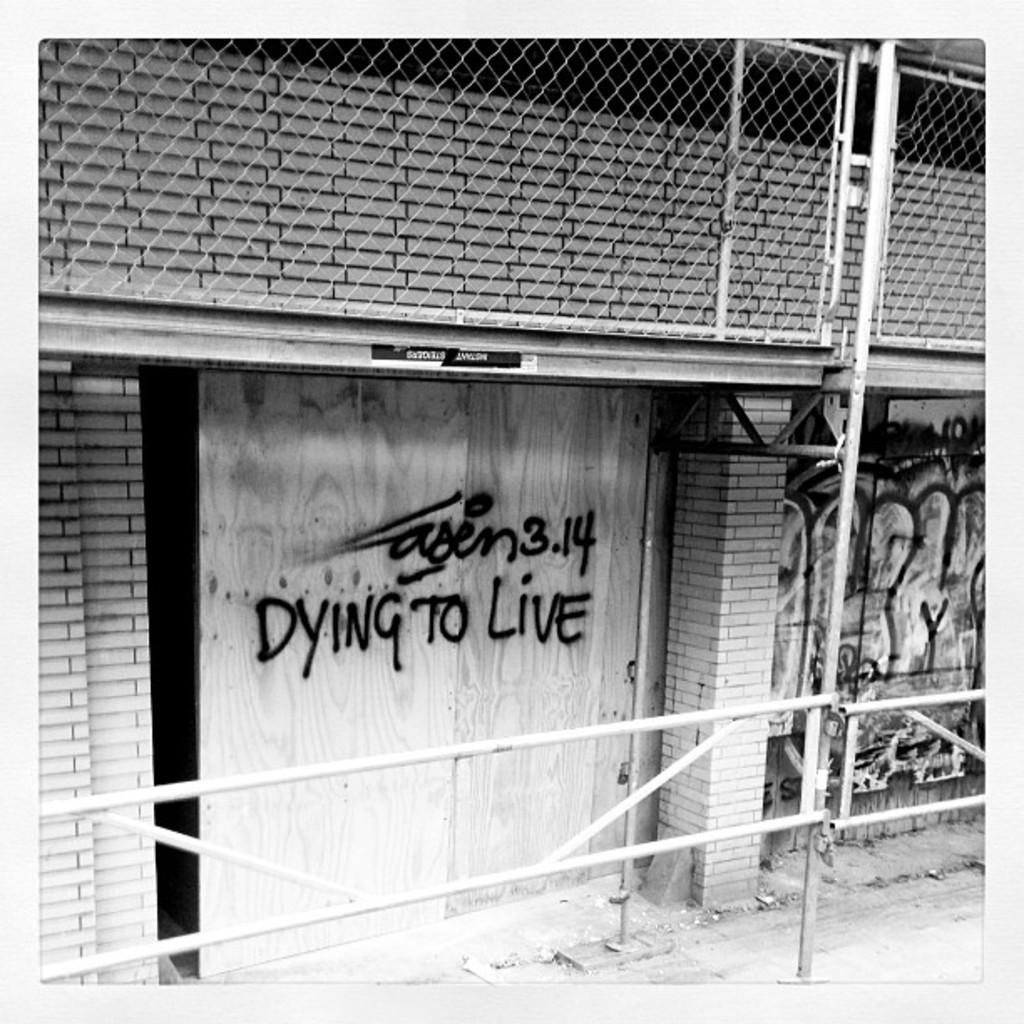What is the color scheme of the image? The image is black and white. What architectural feature can be seen in the image? There is a pillar in the image. What type of structures are present in the image? There are walls in the image. Can you describe a specific detail in the image? There is a mesh in the image. What other objects can be seen in the image? There are poles and rods in the image. Is there any text or writing in the image? Yes, there is writing on a wall in the image. How many beads are hanging from the pillar in the image? There are no beads present in the image. What type of statement can be seen on the train in the image? There are no trains present in the image, so no statements can be seen on them. 